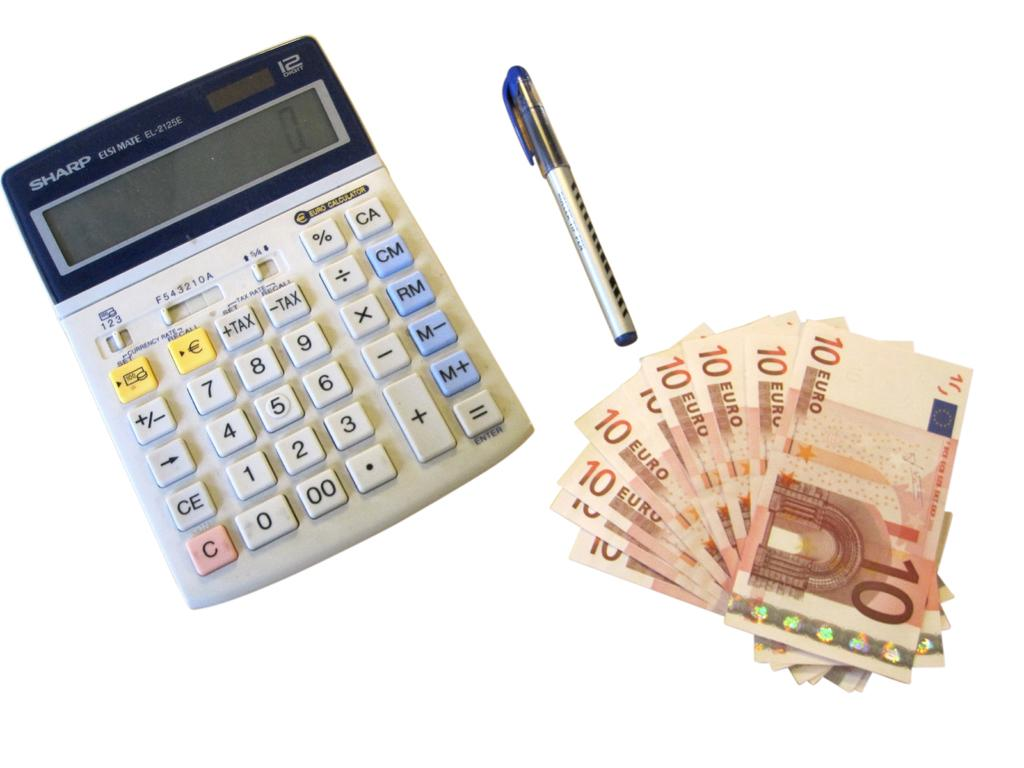<image>
Write a terse but informative summary of the picture. A calculator sits on a white background with a pen to the right of it; underneath are several 10 Euro notes spread out in a fan shape. 